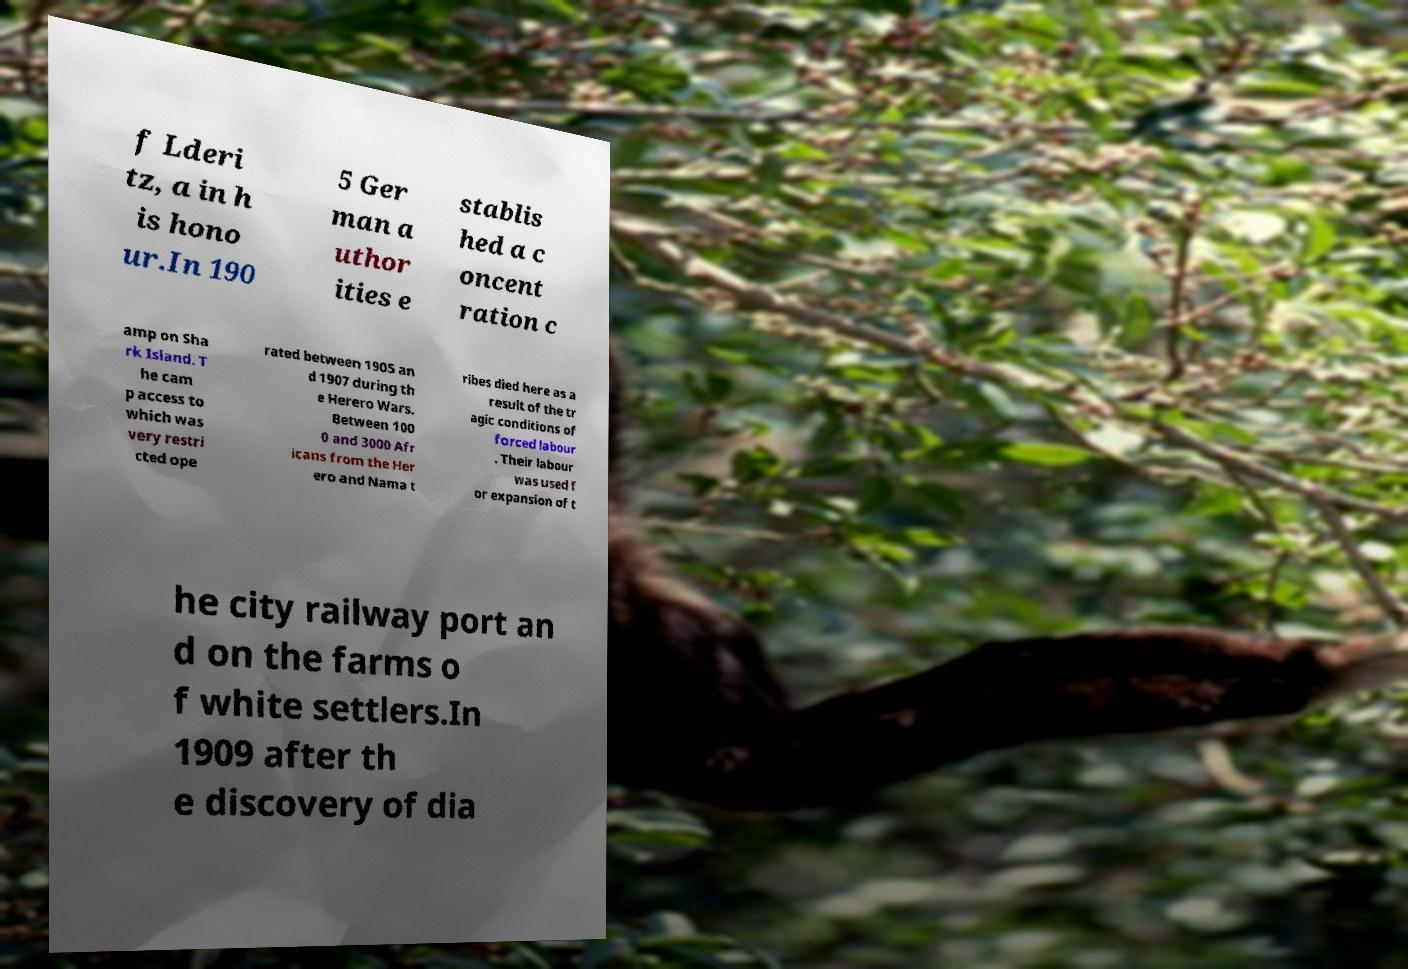There's text embedded in this image that I need extracted. Can you transcribe it verbatim? f Lderi tz, a in h is hono ur.In 190 5 Ger man a uthor ities e stablis hed a c oncent ration c amp on Sha rk Island. T he cam p access to which was very restri cted ope rated between 1905 an d 1907 during th e Herero Wars. Between 100 0 and 3000 Afr icans from the Her ero and Nama t ribes died here as a result of the tr agic conditions of forced labour . Their labour was used f or expansion of t he city railway port an d on the farms o f white settlers.In 1909 after th e discovery of dia 